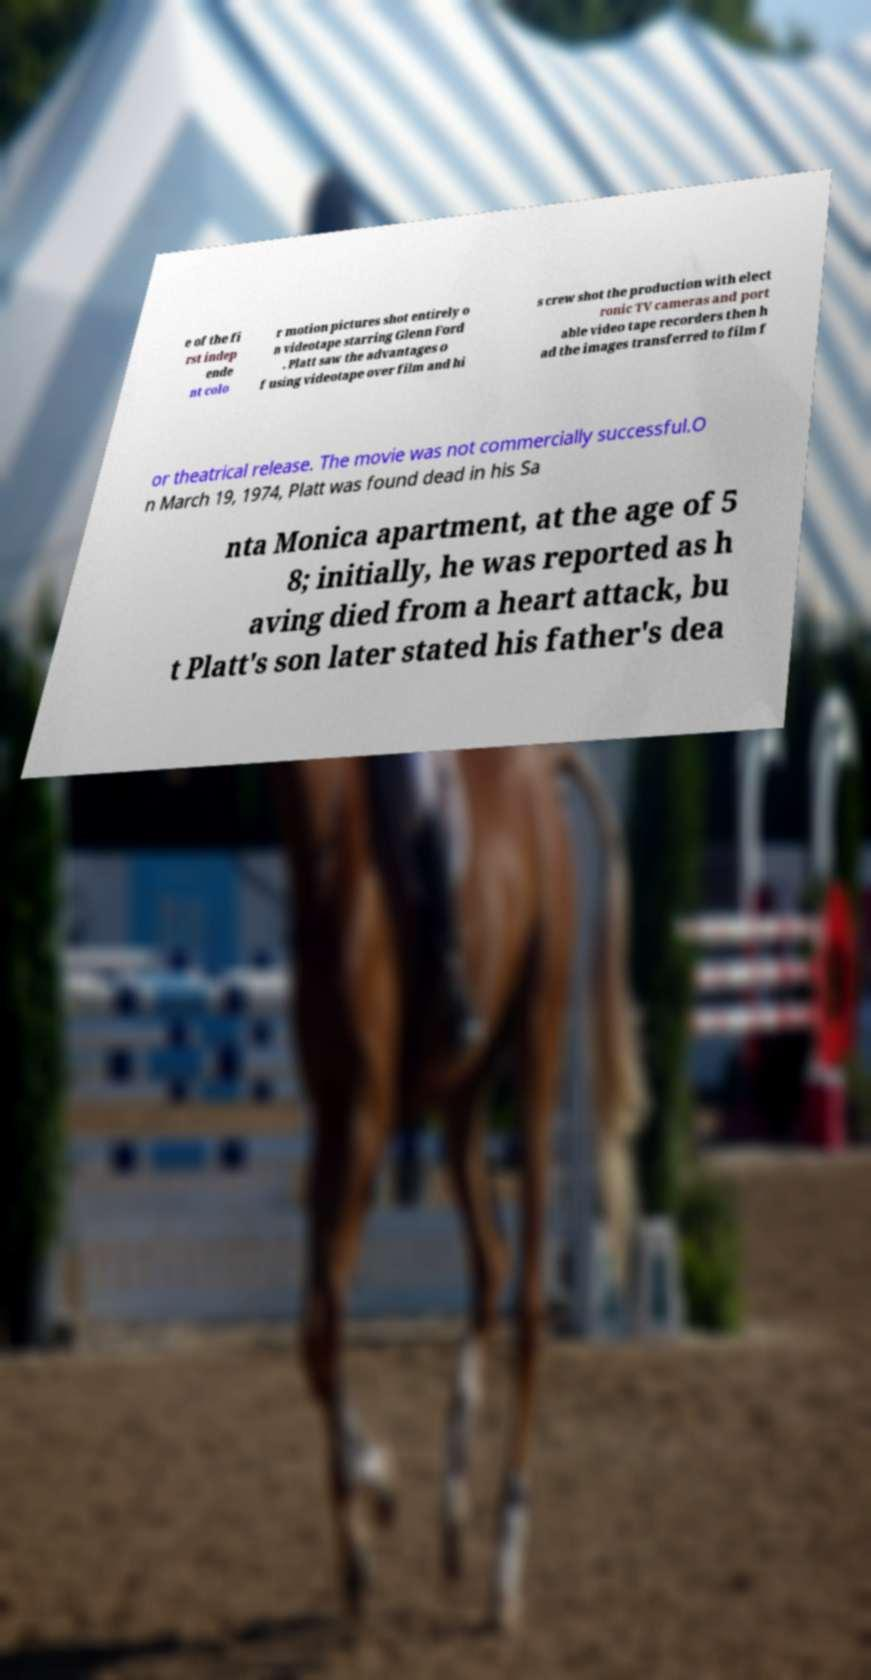I need the written content from this picture converted into text. Can you do that? e of the fi rst indep ende nt colo r motion pictures shot entirely o n videotape starring Glenn Ford . Platt saw the advantages o f using videotape over film and hi s crew shot the production with elect ronic TV cameras and port able video tape recorders then h ad the images transferred to film f or theatrical release. The movie was not commercially successful.O n March 19, 1974, Platt was found dead in his Sa nta Monica apartment, at the age of 5 8; initially, he was reported as h aving died from a heart attack, bu t Platt's son later stated his father's dea 